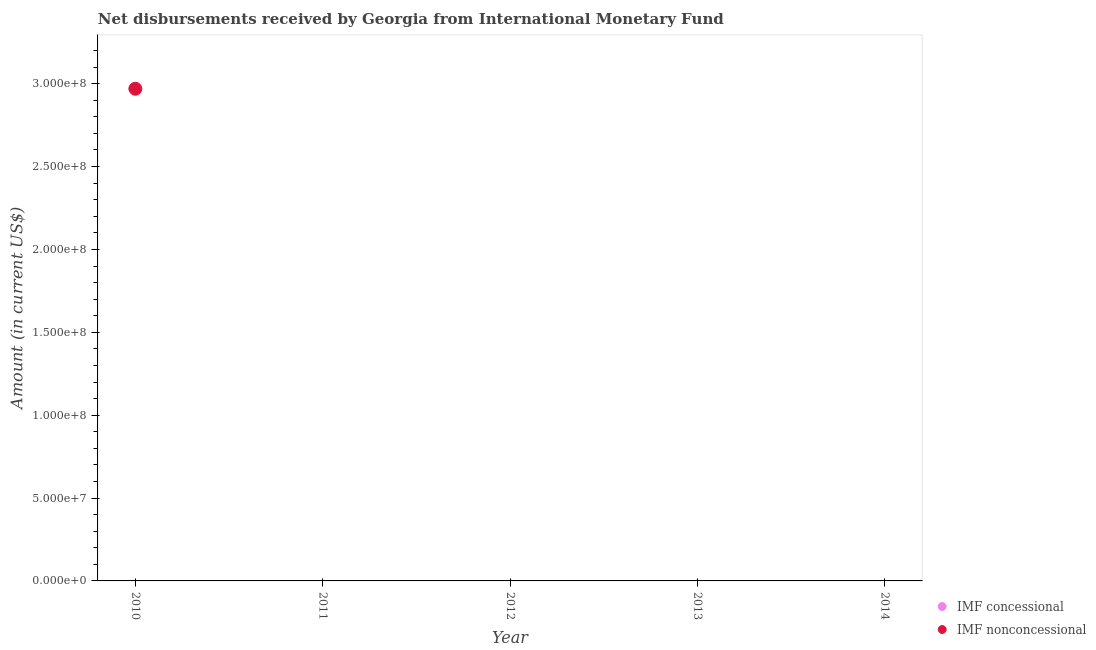Across all years, what is the maximum net non concessional disbursements from imf?
Ensure brevity in your answer.  2.97e+08. In which year was the net non concessional disbursements from imf maximum?
Make the answer very short. 2010. What is the difference between the net non concessional disbursements from imf in 2010 and the net concessional disbursements from imf in 2014?
Your answer should be very brief. 2.97e+08. What is the average net concessional disbursements from imf per year?
Provide a short and direct response. 0. In how many years, is the net concessional disbursements from imf greater than 100000000 US$?
Ensure brevity in your answer.  0. What is the difference between the highest and the lowest net non concessional disbursements from imf?
Offer a very short reply. 2.97e+08. Does the net non concessional disbursements from imf monotonically increase over the years?
Give a very brief answer. No. Does the graph contain grids?
Provide a succinct answer. No. Where does the legend appear in the graph?
Provide a short and direct response. Bottom right. How many legend labels are there?
Your response must be concise. 2. How are the legend labels stacked?
Give a very brief answer. Vertical. What is the title of the graph?
Your answer should be compact. Net disbursements received by Georgia from International Monetary Fund. Does "Study and work" appear as one of the legend labels in the graph?
Provide a short and direct response. No. What is the label or title of the Y-axis?
Give a very brief answer. Amount (in current US$). What is the Amount (in current US$) in IMF nonconcessional in 2010?
Provide a short and direct response. 2.97e+08. What is the Amount (in current US$) in IMF concessional in 2012?
Give a very brief answer. 0. Across all years, what is the maximum Amount (in current US$) in IMF nonconcessional?
Your answer should be compact. 2.97e+08. What is the total Amount (in current US$) of IMF nonconcessional in the graph?
Offer a terse response. 2.97e+08. What is the average Amount (in current US$) in IMF nonconcessional per year?
Keep it short and to the point. 5.94e+07. What is the difference between the highest and the lowest Amount (in current US$) in IMF nonconcessional?
Your response must be concise. 2.97e+08. 